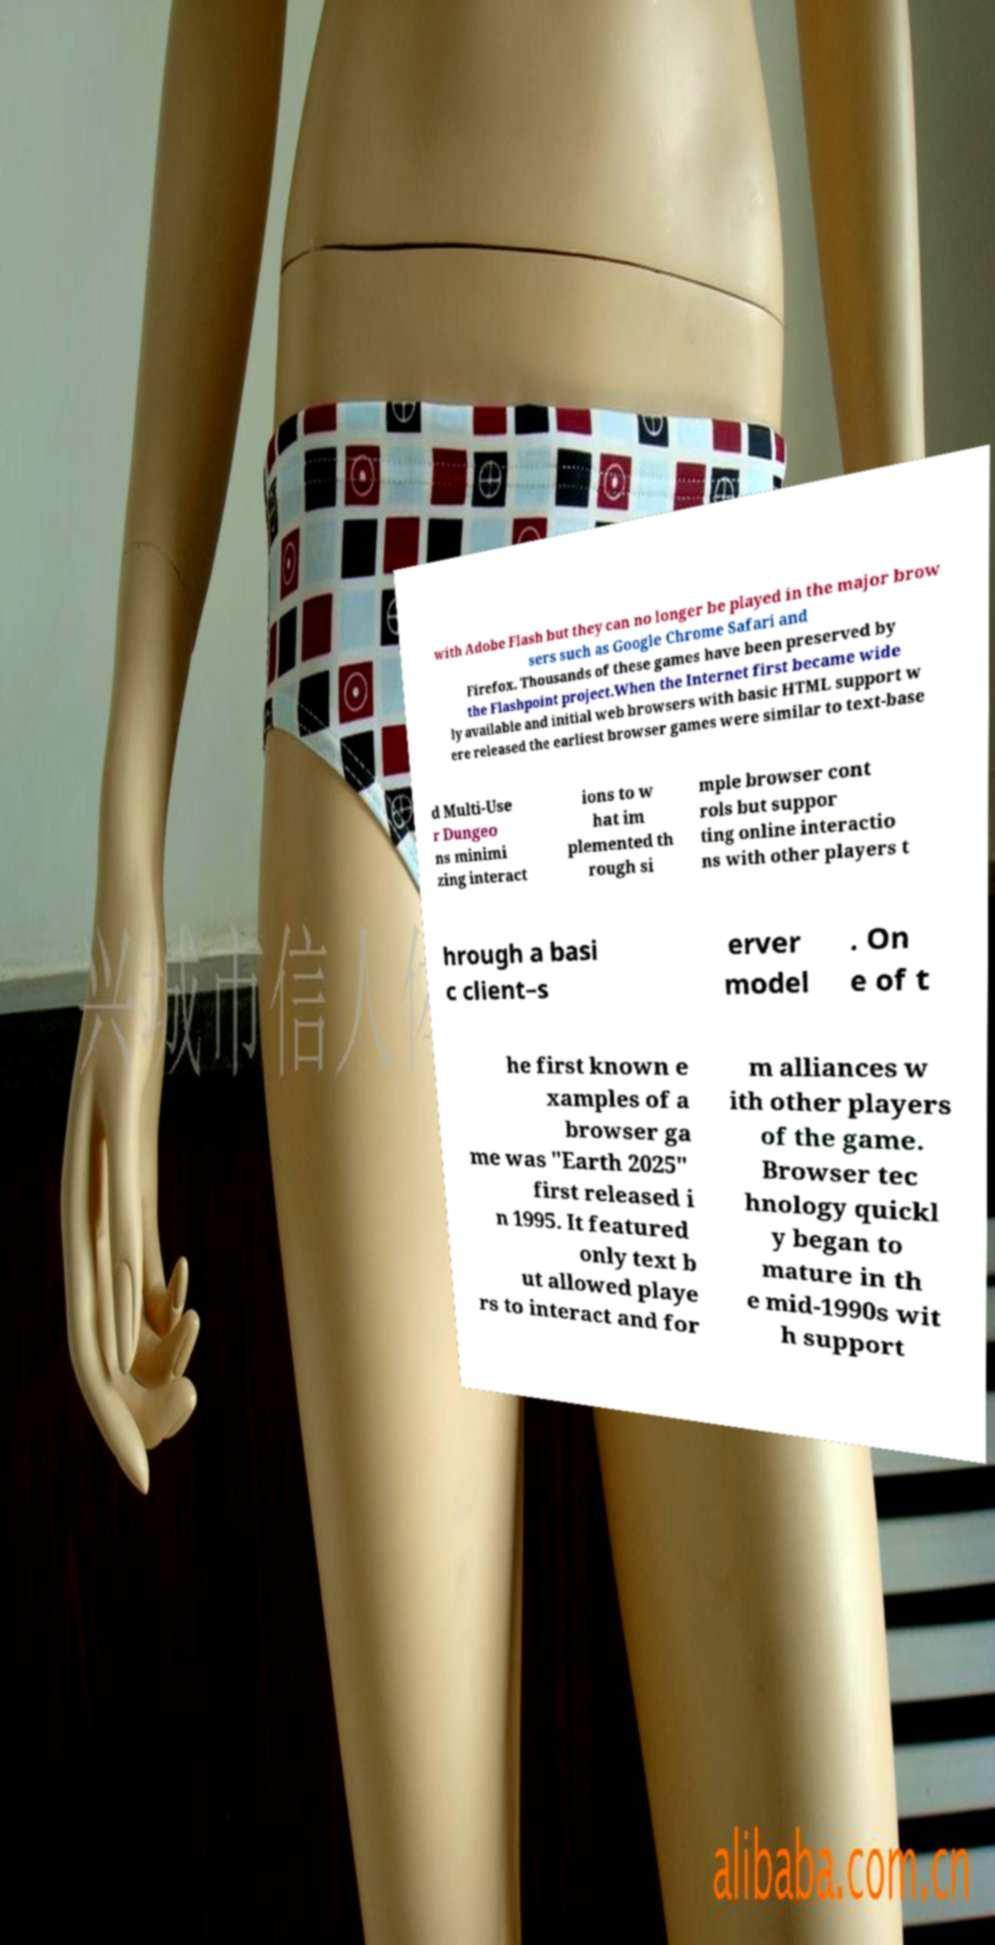I need the written content from this picture converted into text. Can you do that? with Adobe Flash but they can no longer be played in the major brow sers such as Google Chrome Safari and Firefox. Thousands of these games have been preserved by the Flashpoint project.When the Internet first became wide ly available and initial web browsers with basic HTML support w ere released the earliest browser games were similar to text-base d Multi-Use r Dungeo ns minimi zing interact ions to w hat im plemented th rough si mple browser cont rols but suppor ting online interactio ns with other players t hrough a basi c client–s erver model . On e of t he first known e xamples of a browser ga me was "Earth 2025" first released i n 1995. It featured only text b ut allowed playe rs to interact and for m alliances w ith other players of the game. Browser tec hnology quickl y began to mature in th e mid-1990s wit h support 